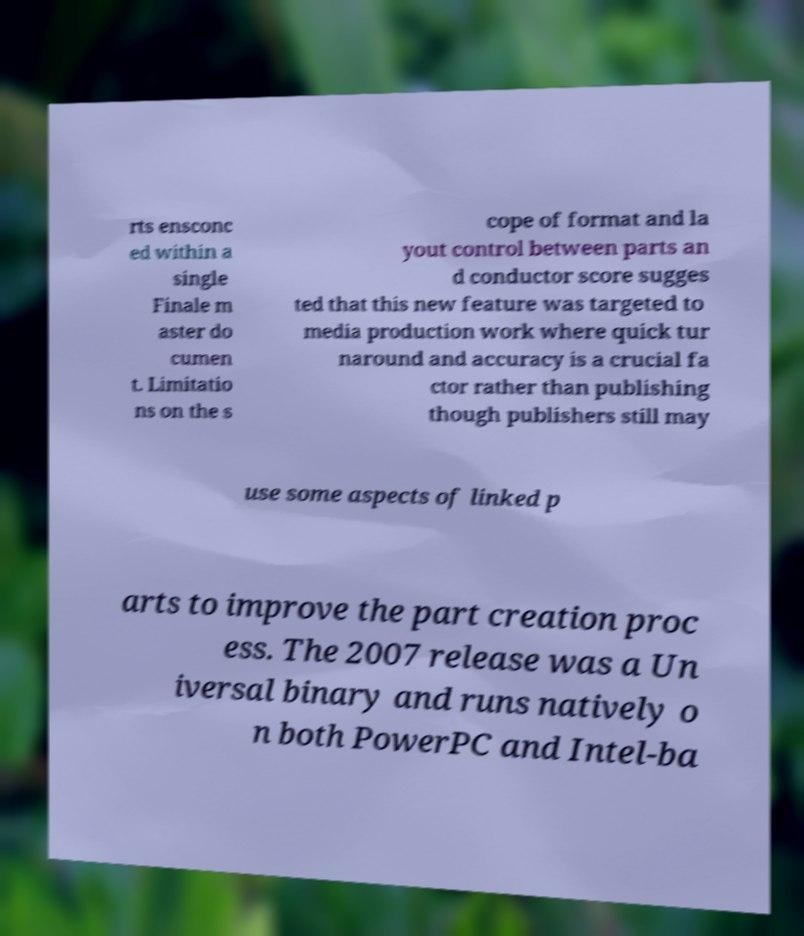Can you accurately transcribe the text from the provided image for me? rts ensconc ed within a single Finale m aster do cumen t. Limitatio ns on the s cope of format and la yout control between parts an d conductor score sugges ted that this new feature was targeted to media production work where quick tur naround and accuracy is a crucial fa ctor rather than publishing though publishers still may use some aspects of linked p arts to improve the part creation proc ess. The 2007 release was a Un iversal binary and runs natively o n both PowerPC and Intel-ba 